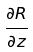<formula> <loc_0><loc_0><loc_500><loc_500>\frac { \partial R } { \partial z }</formula> 